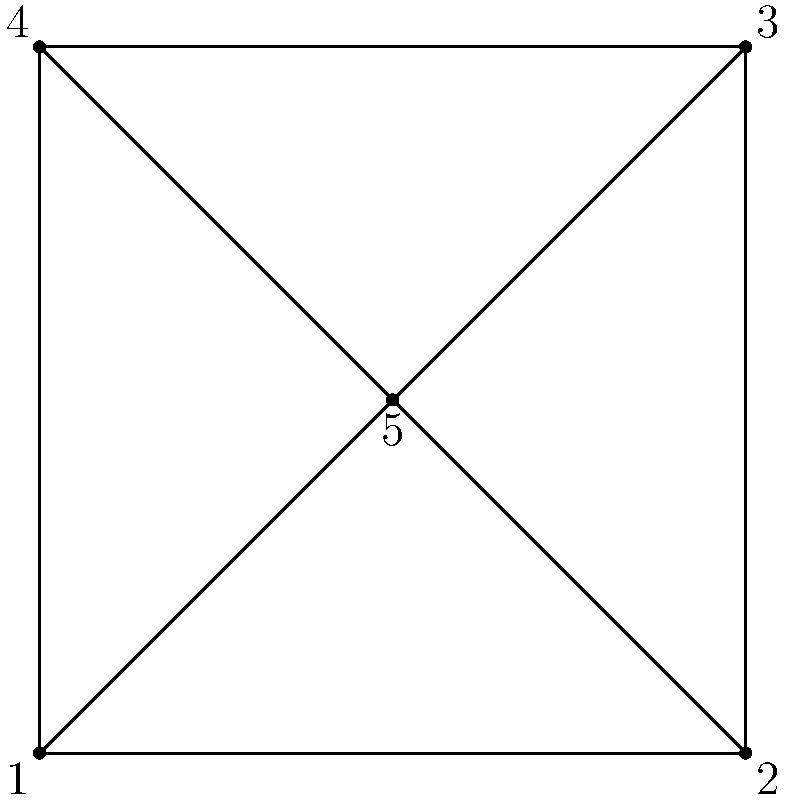In assembling a portable military radio, the steps are represented by the numbers in the diagram. If step 5 must be completed immediately after step 1, and before any other step, what is the correct order of assembly? To determine the correct order of assembly, we need to follow these steps:

1. We know that step 5 must be completed immediately after step 1.
2. The diagram shows connections between all corner points and the center point.
3. To minimize movement and ensure efficiency, we should complete adjacent steps in order.
4. After completing steps 1 and 5, we have three remaining steps (2, 3, and 4).
5. The most logical progression would be to move clockwise or counterclockwise from point 1.
6. Moving clockwise, we would go from 1 to 5, then to 2, 3, and finally 4.

Therefore, the correct order of assembly is: 1, 5, 2, 3, 4.
Answer: 1, 5, 2, 3, 4 